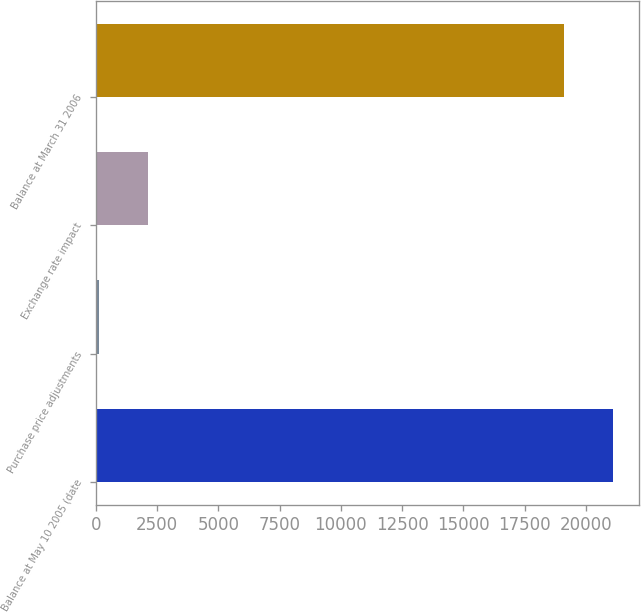Convert chart. <chart><loc_0><loc_0><loc_500><loc_500><bar_chart><fcel>Balance at May 10 2005 (date<fcel>Purchase price adjustments<fcel>Exchange rate impact<fcel>Balance at March 31 2006<nl><fcel>21105.8<fcel>131<fcel>2130.8<fcel>19106<nl></chart> 